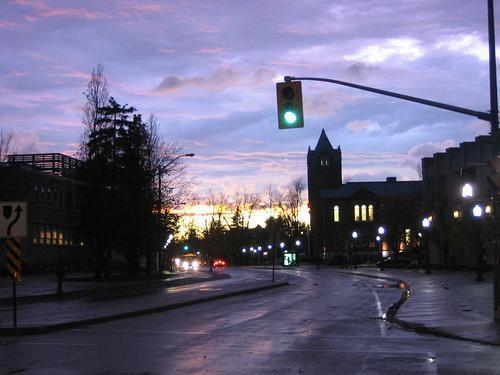How many carrots are on the plate?
Give a very brief answer. 0. 